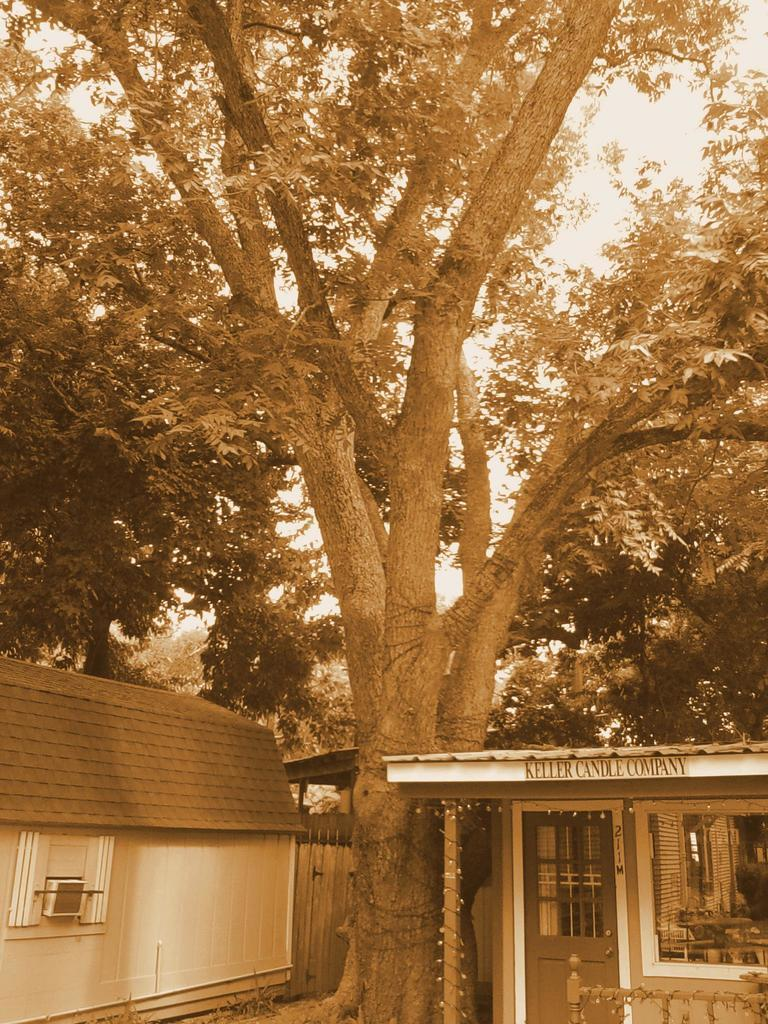What type of structures can be seen in the image? There are houses in the image. What feature do the houses have? The houses have doors. What type of vegetation is present in the image? There are trees in the image. What are the characteristics of the trees? The trees have branches and leaves. What type of business is being conducted in the image? There is no indication of a business being conducted in the image. Is there any evidence of an attack happening in the image? There is no evidence of an attack in the image. 